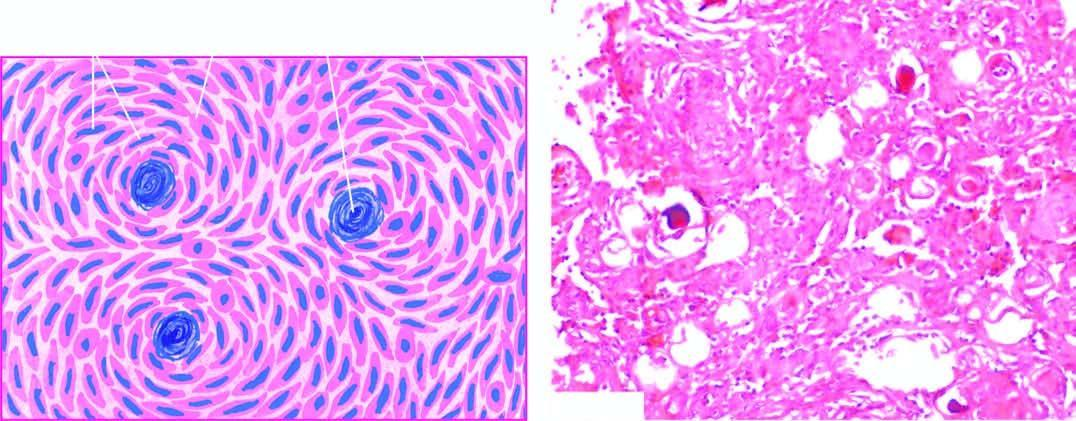what do some of the whorls contain?
Answer the question using a single word or phrase. Psammoma bodies 